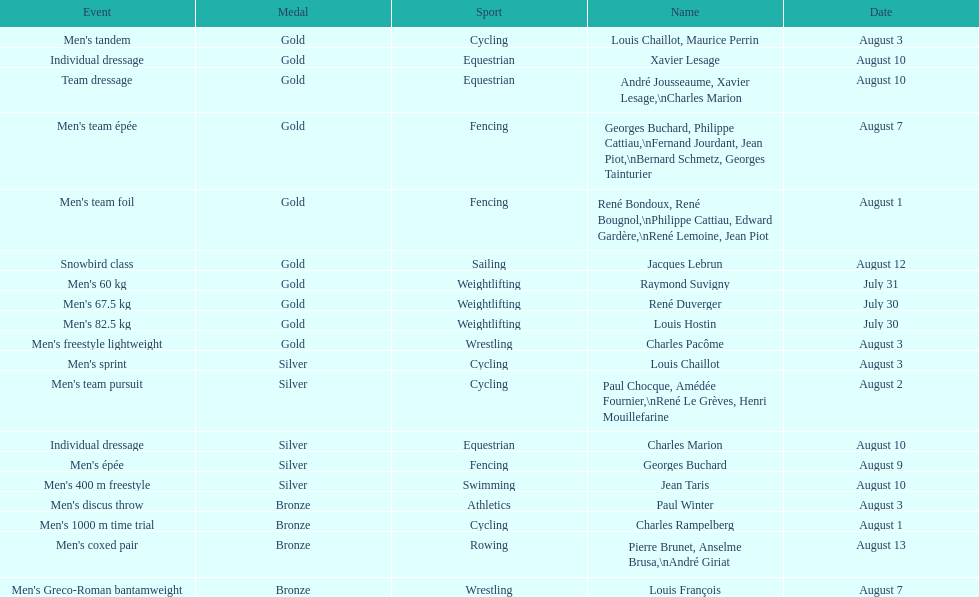What sport is listed first? Cycling. 